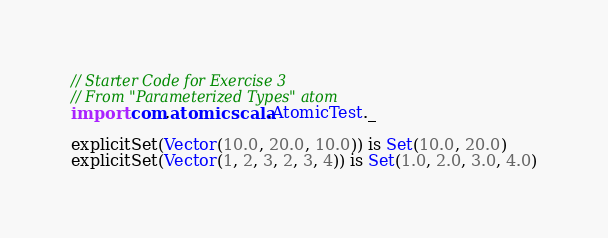<code> <loc_0><loc_0><loc_500><loc_500><_Scala_>// Starter Code for Exercise 3
// From "Parameterized Types" atom
import com.atomicscala.AtomicTest._

explicitSet(Vector(10.0, 20.0, 10.0)) is Set(10.0, 20.0)
explicitSet(Vector(1, 2, 3, 2, 3, 4)) is Set(1.0, 2.0, 3.0, 4.0)
</code> 